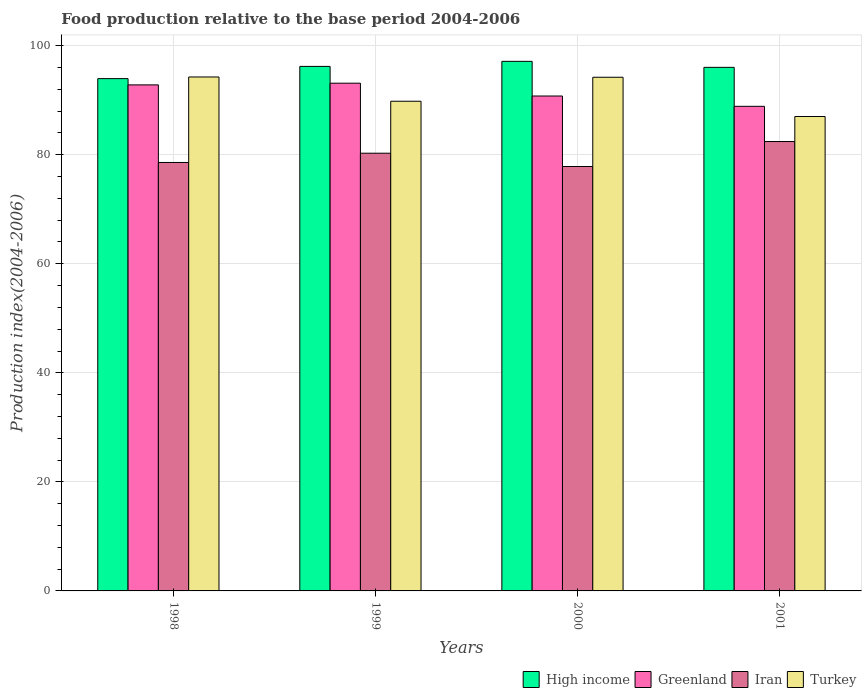How many groups of bars are there?
Your response must be concise. 4. Are the number of bars on each tick of the X-axis equal?
Your answer should be very brief. Yes. How many bars are there on the 2nd tick from the right?
Give a very brief answer. 4. In how many cases, is the number of bars for a given year not equal to the number of legend labels?
Keep it short and to the point. 0. What is the food production index in High income in 2001?
Offer a very short reply. 96.03. Across all years, what is the maximum food production index in High income?
Keep it short and to the point. 97.13. Across all years, what is the minimum food production index in Greenland?
Provide a succinct answer. 88.88. In which year was the food production index in Turkey maximum?
Your answer should be very brief. 1998. In which year was the food production index in Greenland minimum?
Give a very brief answer. 2001. What is the total food production index in Turkey in the graph?
Your answer should be compact. 365.29. What is the difference between the food production index in Turkey in 1998 and that in 1999?
Offer a very short reply. 4.45. What is the difference between the food production index in High income in 2001 and the food production index in Iran in 1999?
Your response must be concise. 15.75. What is the average food production index in Iran per year?
Offer a very short reply. 79.78. In the year 1998, what is the difference between the food production index in High income and food production index in Turkey?
Offer a very short reply. -0.3. What is the ratio of the food production index in Greenland in 1998 to that in 1999?
Your response must be concise. 1. Is the food production index in Turkey in 1998 less than that in 1999?
Make the answer very short. No. What is the difference between the highest and the second highest food production index in Greenland?
Offer a very short reply. 0.31. What is the difference between the highest and the lowest food production index in Iran?
Offer a terse response. 4.58. In how many years, is the food production index in Turkey greater than the average food production index in Turkey taken over all years?
Keep it short and to the point. 2. What does the 2nd bar from the left in 2001 represents?
Your answer should be compact. Greenland. What does the 1st bar from the right in 2000 represents?
Your answer should be compact. Turkey. Is it the case that in every year, the sum of the food production index in Iran and food production index in Turkey is greater than the food production index in High income?
Give a very brief answer. Yes. Are all the bars in the graph horizontal?
Give a very brief answer. No. How many years are there in the graph?
Your answer should be compact. 4. What is the difference between two consecutive major ticks on the Y-axis?
Make the answer very short. 20. Are the values on the major ticks of Y-axis written in scientific E-notation?
Provide a succinct answer. No. How many legend labels are there?
Offer a terse response. 4. How are the legend labels stacked?
Provide a short and direct response. Horizontal. What is the title of the graph?
Keep it short and to the point. Food production relative to the base period 2004-2006. Does "OECD members" appear as one of the legend labels in the graph?
Your answer should be very brief. No. What is the label or title of the X-axis?
Provide a short and direct response. Years. What is the label or title of the Y-axis?
Offer a terse response. Production index(2004-2006). What is the Production index(2004-2006) of High income in 1998?
Ensure brevity in your answer.  93.96. What is the Production index(2004-2006) in Greenland in 1998?
Provide a short and direct response. 92.81. What is the Production index(2004-2006) of Iran in 1998?
Keep it short and to the point. 78.58. What is the Production index(2004-2006) in Turkey in 1998?
Your answer should be compact. 94.26. What is the Production index(2004-2006) of High income in 1999?
Provide a succinct answer. 96.2. What is the Production index(2004-2006) of Greenland in 1999?
Your response must be concise. 93.12. What is the Production index(2004-2006) of Iran in 1999?
Offer a terse response. 80.28. What is the Production index(2004-2006) in Turkey in 1999?
Make the answer very short. 89.81. What is the Production index(2004-2006) of High income in 2000?
Your answer should be compact. 97.13. What is the Production index(2004-2006) in Greenland in 2000?
Your answer should be very brief. 90.77. What is the Production index(2004-2006) of Iran in 2000?
Ensure brevity in your answer.  77.84. What is the Production index(2004-2006) in Turkey in 2000?
Keep it short and to the point. 94.21. What is the Production index(2004-2006) of High income in 2001?
Your answer should be compact. 96.03. What is the Production index(2004-2006) in Greenland in 2001?
Make the answer very short. 88.88. What is the Production index(2004-2006) of Iran in 2001?
Ensure brevity in your answer.  82.42. What is the Production index(2004-2006) of Turkey in 2001?
Keep it short and to the point. 87.01. Across all years, what is the maximum Production index(2004-2006) of High income?
Your answer should be very brief. 97.13. Across all years, what is the maximum Production index(2004-2006) in Greenland?
Give a very brief answer. 93.12. Across all years, what is the maximum Production index(2004-2006) in Iran?
Your answer should be compact. 82.42. Across all years, what is the maximum Production index(2004-2006) in Turkey?
Your answer should be very brief. 94.26. Across all years, what is the minimum Production index(2004-2006) of High income?
Your answer should be very brief. 93.96. Across all years, what is the minimum Production index(2004-2006) in Greenland?
Provide a short and direct response. 88.88. Across all years, what is the minimum Production index(2004-2006) in Iran?
Keep it short and to the point. 77.84. Across all years, what is the minimum Production index(2004-2006) in Turkey?
Your response must be concise. 87.01. What is the total Production index(2004-2006) in High income in the graph?
Ensure brevity in your answer.  383.31. What is the total Production index(2004-2006) in Greenland in the graph?
Offer a very short reply. 365.58. What is the total Production index(2004-2006) in Iran in the graph?
Provide a short and direct response. 319.12. What is the total Production index(2004-2006) in Turkey in the graph?
Your answer should be compact. 365.29. What is the difference between the Production index(2004-2006) of High income in 1998 and that in 1999?
Offer a terse response. -2.25. What is the difference between the Production index(2004-2006) in Greenland in 1998 and that in 1999?
Provide a succinct answer. -0.31. What is the difference between the Production index(2004-2006) in Iran in 1998 and that in 1999?
Your answer should be very brief. -1.7. What is the difference between the Production index(2004-2006) in Turkey in 1998 and that in 1999?
Your response must be concise. 4.45. What is the difference between the Production index(2004-2006) in High income in 1998 and that in 2000?
Provide a short and direct response. -3.17. What is the difference between the Production index(2004-2006) in Greenland in 1998 and that in 2000?
Give a very brief answer. 2.04. What is the difference between the Production index(2004-2006) in Iran in 1998 and that in 2000?
Offer a very short reply. 0.74. What is the difference between the Production index(2004-2006) in Turkey in 1998 and that in 2000?
Your answer should be compact. 0.05. What is the difference between the Production index(2004-2006) of High income in 1998 and that in 2001?
Your answer should be compact. -2.07. What is the difference between the Production index(2004-2006) of Greenland in 1998 and that in 2001?
Provide a succinct answer. 3.93. What is the difference between the Production index(2004-2006) in Iran in 1998 and that in 2001?
Make the answer very short. -3.84. What is the difference between the Production index(2004-2006) in Turkey in 1998 and that in 2001?
Provide a succinct answer. 7.25. What is the difference between the Production index(2004-2006) of High income in 1999 and that in 2000?
Your answer should be compact. -0.92. What is the difference between the Production index(2004-2006) of Greenland in 1999 and that in 2000?
Make the answer very short. 2.35. What is the difference between the Production index(2004-2006) in Iran in 1999 and that in 2000?
Provide a short and direct response. 2.44. What is the difference between the Production index(2004-2006) in High income in 1999 and that in 2001?
Your answer should be compact. 0.18. What is the difference between the Production index(2004-2006) of Greenland in 1999 and that in 2001?
Offer a very short reply. 4.24. What is the difference between the Production index(2004-2006) of Iran in 1999 and that in 2001?
Your response must be concise. -2.14. What is the difference between the Production index(2004-2006) in Turkey in 1999 and that in 2001?
Give a very brief answer. 2.8. What is the difference between the Production index(2004-2006) of High income in 2000 and that in 2001?
Ensure brevity in your answer.  1.1. What is the difference between the Production index(2004-2006) of Greenland in 2000 and that in 2001?
Your answer should be compact. 1.89. What is the difference between the Production index(2004-2006) in Iran in 2000 and that in 2001?
Keep it short and to the point. -4.58. What is the difference between the Production index(2004-2006) of High income in 1998 and the Production index(2004-2006) of Greenland in 1999?
Your answer should be very brief. 0.84. What is the difference between the Production index(2004-2006) of High income in 1998 and the Production index(2004-2006) of Iran in 1999?
Ensure brevity in your answer.  13.68. What is the difference between the Production index(2004-2006) in High income in 1998 and the Production index(2004-2006) in Turkey in 1999?
Your response must be concise. 4.15. What is the difference between the Production index(2004-2006) of Greenland in 1998 and the Production index(2004-2006) of Iran in 1999?
Make the answer very short. 12.53. What is the difference between the Production index(2004-2006) of Iran in 1998 and the Production index(2004-2006) of Turkey in 1999?
Offer a terse response. -11.23. What is the difference between the Production index(2004-2006) in High income in 1998 and the Production index(2004-2006) in Greenland in 2000?
Offer a terse response. 3.19. What is the difference between the Production index(2004-2006) of High income in 1998 and the Production index(2004-2006) of Iran in 2000?
Your answer should be compact. 16.12. What is the difference between the Production index(2004-2006) of High income in 1998 and the Production index(2004-2006) of Turkey in 2000?
Your answer should be very brief. -0.25. What is the difference between the Production index(2004-2006) in Greenland in 1998 and the Production index(2004-2006) in Iran in 2000?
Your answer should be very brief. 14.97. What is the difference between the Production index(2004-2006) in Greenland in 1998 and the Production index(2004-2006) in Turkey in 2000?
Make the answer very short. -1.4. What is the difference between the Production index(2004-2006) in Iran in 1998 and the Production index(2004-2006) in Turkey in 2000?
Offer a very short reply. -15.63. What is the difference between the Production index(2004-2006) of High income in 1998 and the Production index(2004-2006) of Greenland in 2001?
Provide a succinct answer. 5.08. What is the difference between the Production index(2004-2006) of High income in 1998 and the Production index(2004-2006) of Iran in 2001?
Your answer should be compact. 11.54. What is the difference between the Production index(2004-2006) in High income in 1998 and the Production index(2004-2006) in Turkey in 2001?
Offer a terse response. 6.95. What is the difference between the Production index(2004-2006) in Greenland in 1998 and the Production index(2004-2006) in Iran in 2001?
Ensure brevity in your answer.  10.39. What is the difference between the Production index(2004-2006) of Greenland in 1998 and the Production index(2004-2006) of Turkey in 2001?
Keep it short and to the point. 5.8. What is the difference between the Production index(2004-2006) of Iran in 1998 and the Production index(2004-2006) of Turkey in 2001?
Your answer should be very brief. -8.43. What is the difference between the Production index(2004-2006) of High income in 1999 and the Production index(2004-2006) of Greenland in 2000?
Ensure brevity in your answer.  5.43. What is the difference between the Production index(2004-2006) in High income in 1999 and the Production index(2004-2006) in Iran in 2000?
Your answer should be compact. 18.36. What is the difference between the Production index(2004-2006) in High income in 1999 and the Production index(2004-2006) in Turkey in 2000?
Provide a succinct answer. 1.99. What is the difference between the Production index(2004-2006) of Greenland in 1999 and the Production index(2004-2006) of Iran in 2000?
Keep it short and to the point. 15.28. What is the difference between the Production index(2004-2006) in Greenland in 1999 and the Production index(2004-2006) in Turkey in 2000?
Make the answer very short. -1.09. What is the difference between the Production index(2004-2006) of Iran in 1999 and the Production index(2004-2006) of Turkey in 2000?
Your answer should be compact. -13.93. What is the difference between the Production index(2004-2006) of High income in 1999 and the Production index(2004-2006) of Greenland in 2001?
Offer a very short reply. 7.32. What is the difference between the Production index(2004-2006) in High income in 1999 and the Production index(2004-2006) in Iran in 2001?
Your answer should be compact. 13.78. What is the difference between the Production index(2004-2006) of High income in 1999 and the Production index(2004-2006) of Turkey in 2001?
Your response must be concise. 9.19. What is the difference between the Production index(2004-2006) of Greenland in 1999 and the Production index(2004-2006) of Iran in 2001?
Offer a terse response. 10.7. What is the difference between the Production index(2004-2006) in Greenland in 1999 and the Production index(2004-2006) in Turkey in 2001?
Provide a short and direct response. 6.11. What is the difference between the Production index(2004-2006) in Iran in 1999 and the Production index(2004-2006) in Turkey in 2001?
Keep it short and to the point. -6.73. What is the difference between the Production index(2004-2006) in High income in 2000 and the Production index(2004-2006) in Greenland in 2001?
Ensure brevity in your answer.  8.25. What is the difference between the Production index(2004-2006) of High income in 2000 and the Production index(2004-2006) of Iran in 2001?
Offer a terse response. 14.71. What is the difference between the Production index(2004-2006) in High income in 2000 and the Production index(2004-2006) in Turkey in 2001?
Keep it short and to the point. 10.12. What is the difference between the Production index(2004-2006) in Greenland in 2000 and the Production index(2004-2006) in Iran in 2001?
Keep it short and to the point. 8.35. What is the difference between the Production index(2004-2006) in Greenland in 2000 and the Production index(2004-2006) in Turkey in 2001?
Offer a terse response. 3.76. What is the difference between the Production index(2004-2006) of Iran in 2000 and the Production index(2004-2006) of Turkey in 2001?
Keep it short and to the point. -9.17. What is the average Production index(2004-2006) of High income per year?
Keep it short and to the point. 95.83. What is the average Production index(2004-2006) in Greenland per year?
Offer a very short reply. 91.39. What is the average Production index(2004-2006) of Iran per year?
Your answer should be compact. 79.78. What is the average Production index(2004-2006) of Turkey per year?
Provide a short and direct response. 91.32. In the year 1998, what is the difference between the Production index(2004-2006) of High income and Production index(2004-2006) of Greenland?
Offer a very short reply. 1.15. In the year 1998, what is the difference between the Production index(2004-2006) of High income and Production index(2004-2006) of Iran?
Your answer should be compact. 15.38. In the year 1998, what is the difference between the Production index(2004-2006) of High income and Production index(2004-2006) of Turkey?
Offer a terse response. -0.3. In the year 1998, what is the difference between the Production index(2004-2006) of Greenland and Production index(2004-2006) of Iran?
Your answer should be compact. 14.23. In the year 1998, what is the difference between the Production index(2004-2006) in Greenland and Production index(2004-2006) in Turkey?
Your response must be concise. -1.45. In the year 1998, what is the difference between the Production index(2004-2006) in Iran and Production index(2004-2006) in Turkey?
Provide a succinct answer. -15.68. In the year 1999, what is the difference between the Production index(2004-2006) in High income and Production index(2004-2006) in Greenland?
Keep it short and to the point. 3.08. In the year 1999, what is the difference between the Production index(2004-2006) in High income and Production index(2004-2006) in Iran?
Give a very brief answer. 15.92. In the year 1999, what is the difference between the Production index(2004-2006) in High income and Production index(2004-2006) in Turkey?
Offer a very short reply. 6.39. In the year 1999, what is the difference between the Production index(2004-2006) in Greenland and Production index(2004-2006) in Iran?
Your answer should be very brief. 12.84. In the year 1999, what is the difference between the Production index(2004-2006) in Greenland and Production index(2004-2006) in Turkey?
Make the answer very short. 3.31. In the year 1999, what is the difference between the Production index(2004-2006) in Iran and Production index(2004-2006) in Turkey?
Ensure brevity in your answer.  -9.53. In the year 2000, what is the difference between the Production index(2004-2006) in High income and Production index(2004-2006) in Greenland?
Your answer should be very brief. 6.36. In the year 2000, what is the difference between the Production index(2004-2006) of High income and Production index(2004-2006) of Iran?
Your response must be concise. 19.29. In the year 2000, what is the difference between the Production index(2004-2006) of High income and Production index(2004-2006) of Turkey?
Your response must be concise. 2.92. In the year 2000, what is the difference between the Production index(2004-2006) in Greenland and Production index(2004-2006) in Iran?
Your response must be concise. 12.93. In the year 2000, what is the difference between the Production index(2004-2006) in Greenland and Production index(2004-2006) in Turkey?
Ensure brevity in your answer.  -3.44. In the year 2000, what is the difference between the Production index(2004-2006) in Iran and Production index(2004-2006) in Turkey?
Ensure brevity in your answer.  -16.37. In the year 2001, what is the difference between the Production index(2004-2006) of High income and Production index(2004-2006) of Greenland?
Provide a short and direct response. 7.15. In the year 2001, what is the difference between the Production index(2004-2006) in High income and Production index(2004-2006) in Iran?
Your response must be concise. 13.61. In the year 2001, what is the difference between the Production index(2004-2006) of High income and Production index(2004-2006) of Turkey?
Your answer should be compact. 9.02. In the year 2001, what is the difference between the Production index(2004-2006) of Greenland and Production index(2004-2006) of Iran?
Your answer should be very brief. 6.46. In the year 2001, what is the difference between the Production index(2004-2006) of Greenland and Production index(2004-2006) of Turkey?
Offer a terse response. 1.87. In the year 2001, what is the difference between the Production index(2004-2006) in Iran and Production index(2004-2006) in Turkey?
Your answer should be very brief. -4.59. What is the ratio of the Production index(2004-2006) of High income in 1998 to that in 1999?
Keep it short and to the point. 0.98. What is the ratio of the Production index(2004-2006) in Greenland in 1998 to that in 1999?
Your answer should be very brief. 1. What is the ratio of the Production index(2004-2006) in Iran in 1998 to that in 1999?
Ensure brevity in your answer.  0.98. What is the ratio of the Production index(2004-2006) of Turkey in 1998 to that in 1999?
Ensure brevity in your answer.  1.05. What is the ratio of the Production index(2004-2006) of High income in 1998 to that in 2000?
Offer a terse response. 0.97. What is the ratio of the Production index(2004-2006) in Greenland in 1998 to that in 2000?
Your response must be concise. 1.02. What is the ratio of the Production index(2004-2006) in Iran in 1998 to that in 2000?
Your response must be concise. 1.01. What is the ratio of the Production index(2004-2006) of High income in 1998 to that in 2001?
Your answer should be very brief. 0.98. What is the ratio of the Production index(2004-2006) of Greenland in 1998 to that in 2001?
Keep it short and to the point. 1.04. What is the ratio of the Production index(2004-2006) in Iran in 1998 to that in 2001?
Keep it short and to the point. 0.95. What is the ratio of the Production index(2004-2006) in Turkey in 1998 to that in 2001?
Provide a succinct answer. 1.08. What is the ratio of the Production index(2004-2006) of High income in 1999 to that in 2000?
Provide a short and direct response. 0.99. What is the ratio of the Production index(2004-2006) of Greenland in 1999 to that in 2000?
Your answer should be compact. 1.03. What is the ratio of the Production index(2004-2006) in Iran in 1999 to that in 2000?
Ensure brevity in your answer.  1.03. What is the ratio of the Production index(2004-2006) of Turkey in 1999 to that in 2000?
Your answer should be very brief. 0.95. What is the ratio of the Production index(2004-2006) of Greenland in 1999 to that in 2001?
Keep it short and to the point. 1.05. What is the ratio of the Production index(2004-2006) of Turkey in 1999 to that in 2001?
Keep it short and to the point. 1.03. What is the ratio of the Production index(2004-2006) in High income in 2000 to that in 2001?
Provide a succinct answer. 1.01. What is the ratio of the Production index(2004-2006) of Greenland in 2000 to that in 2001?
Your answer should be compact. 1.02. What is the ratio of the Production index(2004-2006) in Iran in 2000 to that in 2001?
Your answer should be compact. 0.94. What is the ratio of the Production index(2004-2006) of Turkey in 2000 to that in 2001?
Make the answer very short. 1.08. What is the difference between the highest and the second highest Production index(2004-2006) in High income?
Provide a short and direct response. 0.92. What is the difference between the highest and the second highest Production index(2004-2006) in Greenland?
Your answer should be compact. 0.31. What is the difference between the highest and the second highest Production index(2004-2006) in Iran?
Your answer should be very brief. 2.14. What is the difference between the highest and the second highest Production index(2004-2006) of Turkey?
Your answer should be very brief. 0.05. What is the difference between the highest and the lowest Production index(2004-2006) of High income?
Provide a short and direct response. 3.17. What is the difference between the highest and the lowest Production index(2004-2006) of Greenland?
Your answer should be very brief. 4.24. What is the difference between the highest and the lowest Production index(2004-2006) in Iran?
Offer a very short reply. 4.58. What is the difference between the highest and the lowest Production index(2004-2006) of Turkey?
Offer a terse response. 7.25. 